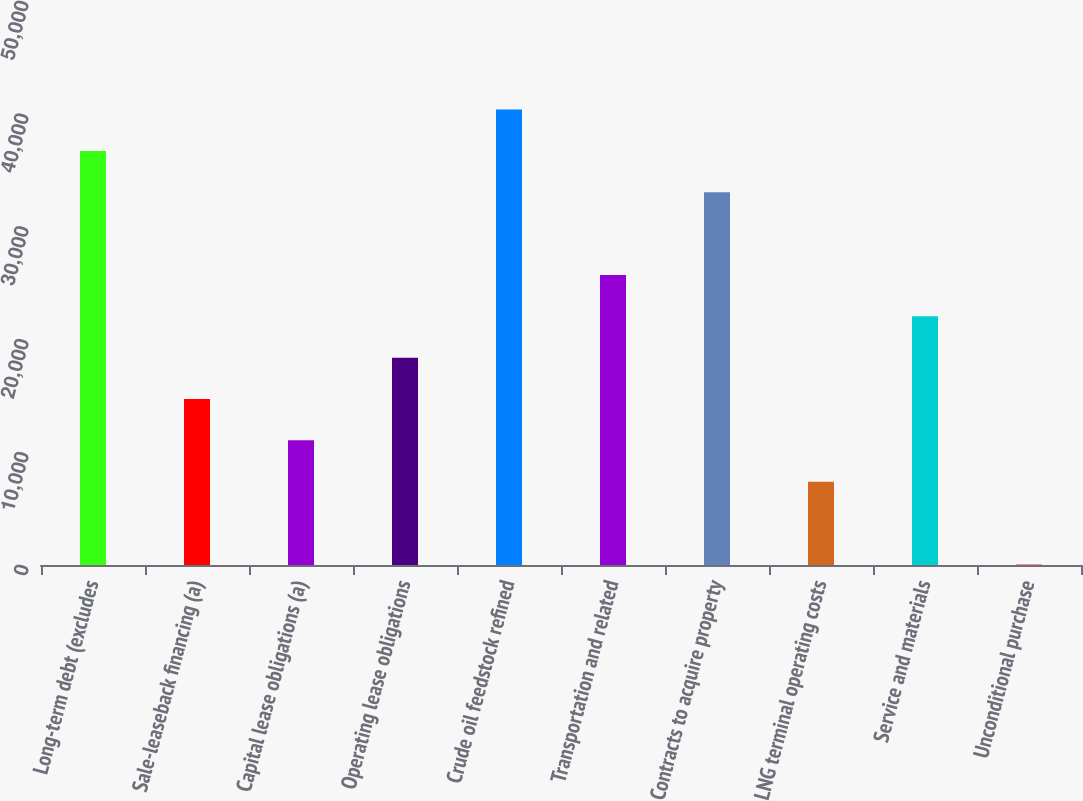<chart> <loc_0><loc_0><loc_500><loc_500><bar_chart><fcel>Long-term debt (excludes<fcel>Sale-leaseback financing (a)<fcel>Capital lease obligations (a)<fcel>Operating lease obligations<fcel>Crude oil feedstock refined<fcel>Transportation and related<fcel>Contracts to acquire property<fcel>LNG terminal operating costs<fcel>Service and materials<fcel>Unconditional purchase<nl><fcel>36708<fcel>14718.6<fcel>11053.7<fcel>18383.5<fcel>40372.9<fcel>25713.3<fcel>33043.1<fcel>7388.8<fcel>22048.4<fcel>59<nl></chart> 